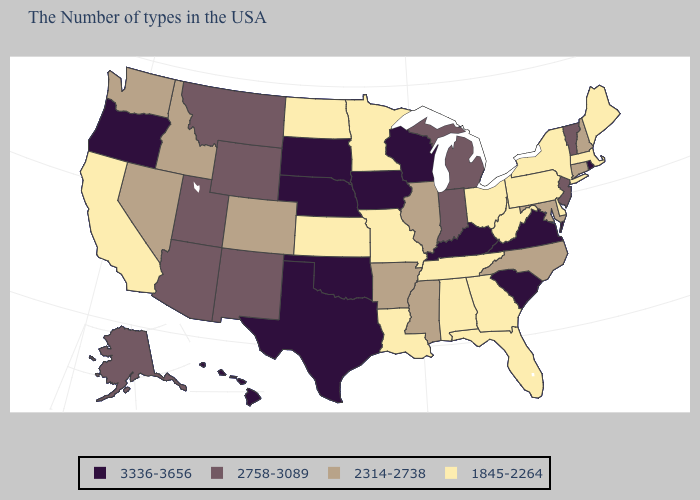What is the highest value in states that border North Carolina?
Keep it brief. 3336-3656. Name the states that have a value in the range 1845-2264?
Short answer required. Maine, Massachusetts, New York, Delaware, Pennsylvania, West Virginia, Ohio, Florida, Georgia, Alabama, Tennessee, Louisiana, Missouri, Minnesota, Kansas, North Dakota, California. What is the value of New Jersey?
Quick response, please. 2758-3089. Does Tennessee have the lowest value in the USA?
Short answer required. Yes. What is the value of Indiana?
Write a very short answer. 2758-3089. What is the value of Georgia?
Keep it brief. 1845-2264. Among the states that border Oregon , which have the lowest value?
Short answer required. California. What is the highest value in the USA?
Concise answer only. 3336-3656. What is the value of Virginia?
Answer briefly. 3336-3656. Does the map have missing data?
Short answer required. No. Does South Dakota have the highest value in the USA?
Short answer required. Yes. Name the states that have a value in the range 2758-3089?
Short answer required. Vermont, New Jersey, Michigan, Indiana, Wyoming, New Mexico, Utah, Montana, Arizona, Alaska. Which states have the lowest value in the South?
Write a very short answer. Delaware, West Virginia, Florida, Georgia, Alabama, Tennessee, Louisiana. Does Arizona have a lower value than Michigan?
Concise answer only. No. What is the lowest value in states that border Arizona?
Quick response, please. 1845-2264. 